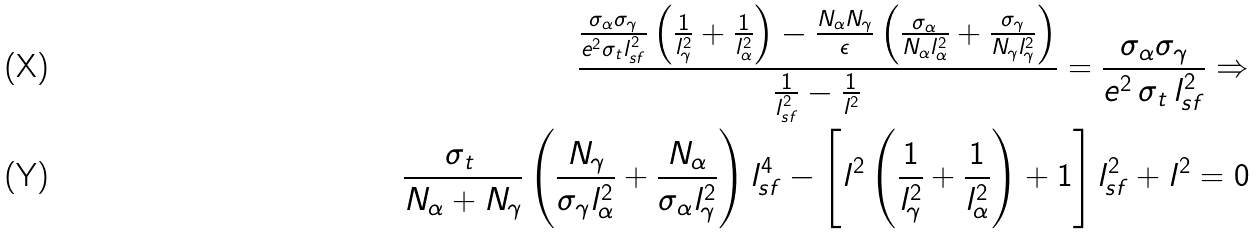Convert formula to latex. <formula><loc_0><loc_0><loc_500><loc_500>\frac { \frac { \sigma _ { \alpha } \sigma _ { \gamma } } { e ^ { 2 } \sigma _ { t } l ^ { 2 } _ { s f } } \left ( \frac { 1 } { l _ { \gamma } ^ { 2 } } + \frac { 1 } { l _ { \alpha } ^ { 2 } } \right ) - \frac { N _ { \alpha } N _ { \gamma } } { \epsilon } \left ( \frac { \sigma _ { \alpha } } { N _ { \alpha } l _ { \alpha } ^ { 2 } } + \frac { \sigma _ { \gamma } } { N _ { \gamma } l _ { \gamma } ^ { 2 } } \right ) } { \frac { 1 } { l _ { s f } ^ { 2 } } - \frac { 1 } { l ^ { 2 } } } = \frac { \sigma _ { \alpha } \sigma _ { \gamma } } { e ^ { 2 } \, \sigma _ { t } \, l _ { s f } ^ { 2 } } \Rightarrow \\ \frac { \sigma _ { t } \, } { N _ { \alpha } + N _ { \gamma } } \left ( \frac { N _ { \gamma } } { \sigma _ { \gamma } l _ { \alpha } ^ { 2 } } + \frac { N _ { \alpha } } { \sigma _ { \alpha } l _ { \gamma } ^ { 2 } } \right ) l _ { s f } ^ { 4 } - \left [ l ^ { 2 } \left ( \frac { 1 } { l _ { \gamma } ^ { 2 } } + \frac { 1 } { l _ { \alpha } ^ { 2 } } \right ) + 1 \right ] l _ { s f } ^ { 2 } + l ^ { 2 } = 0</formula> 